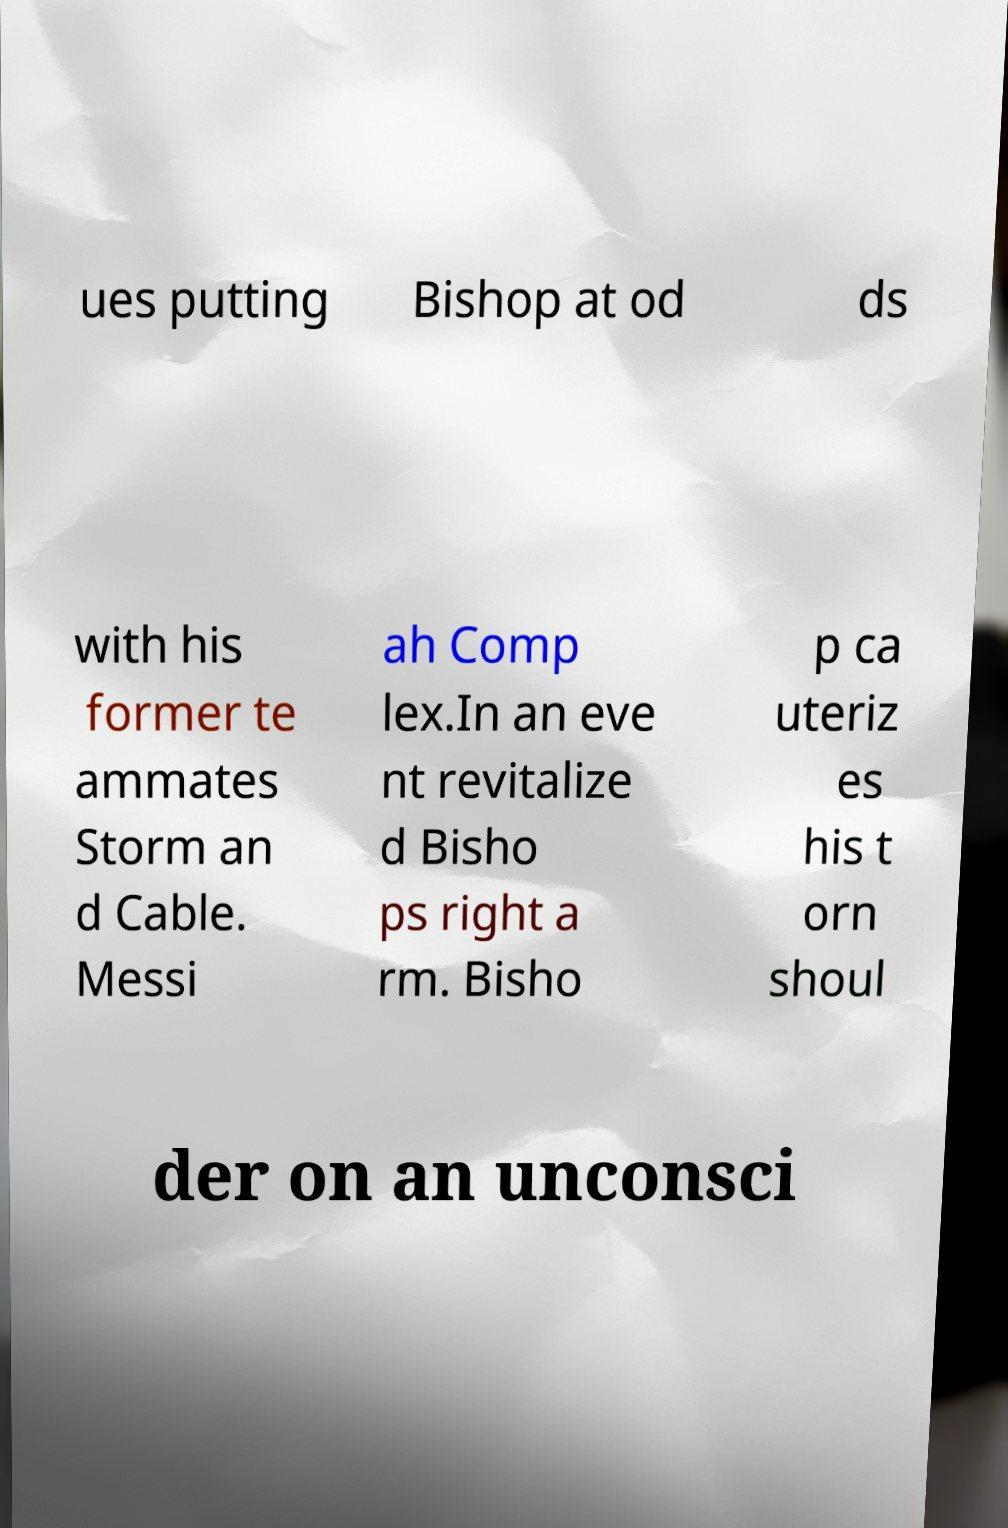Could you assist in decoding the text presented in this image and type it out clearly? ues putting Bishop at od ds with his former te ammates Storm an d Cable. Messi ah Comp lex.In an eve nt revitalize d Bisho ps right a rm. Bisho p ca uteriz es his t orn shoul der on an unconsci 